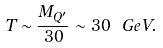Convert formula to latex. <formula><loc_0><loc_0><loc_500><loc_500>T \sim \frac { M _ { Q ^ { \prime } } } { 3 0 } \sim 3 0 \ G e V .</formula> 